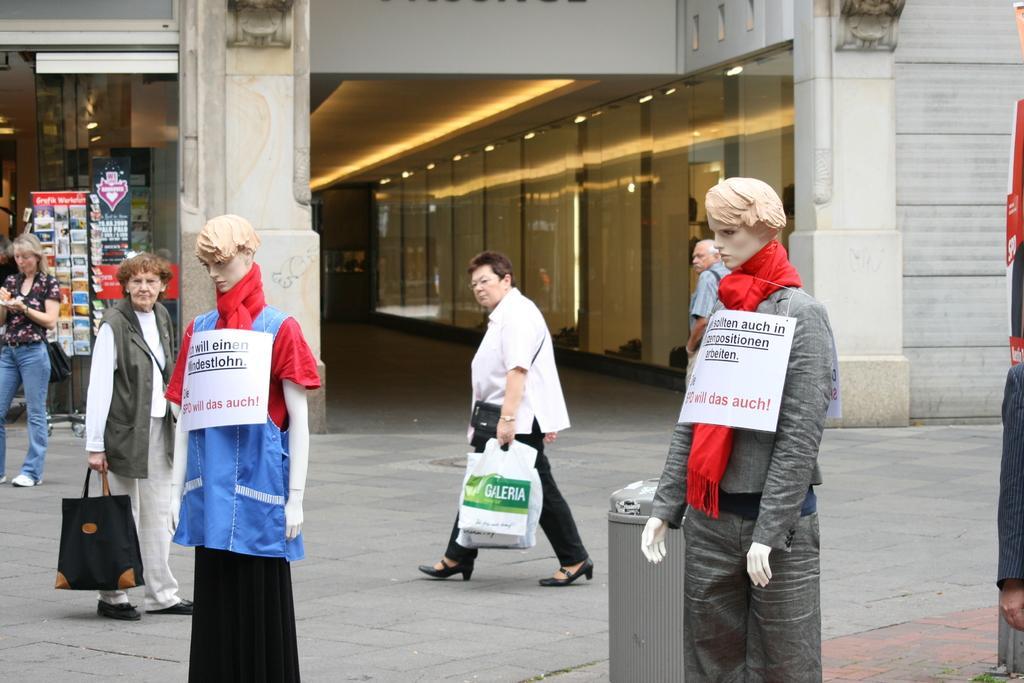Can you describe this image briefly? In this image we can see a building. There are few people are walking in the image. There are two mannequins and some boards are hanged in their heads. There is a store in the image. There are many books placed on the rack. There are many lamps in the image. 